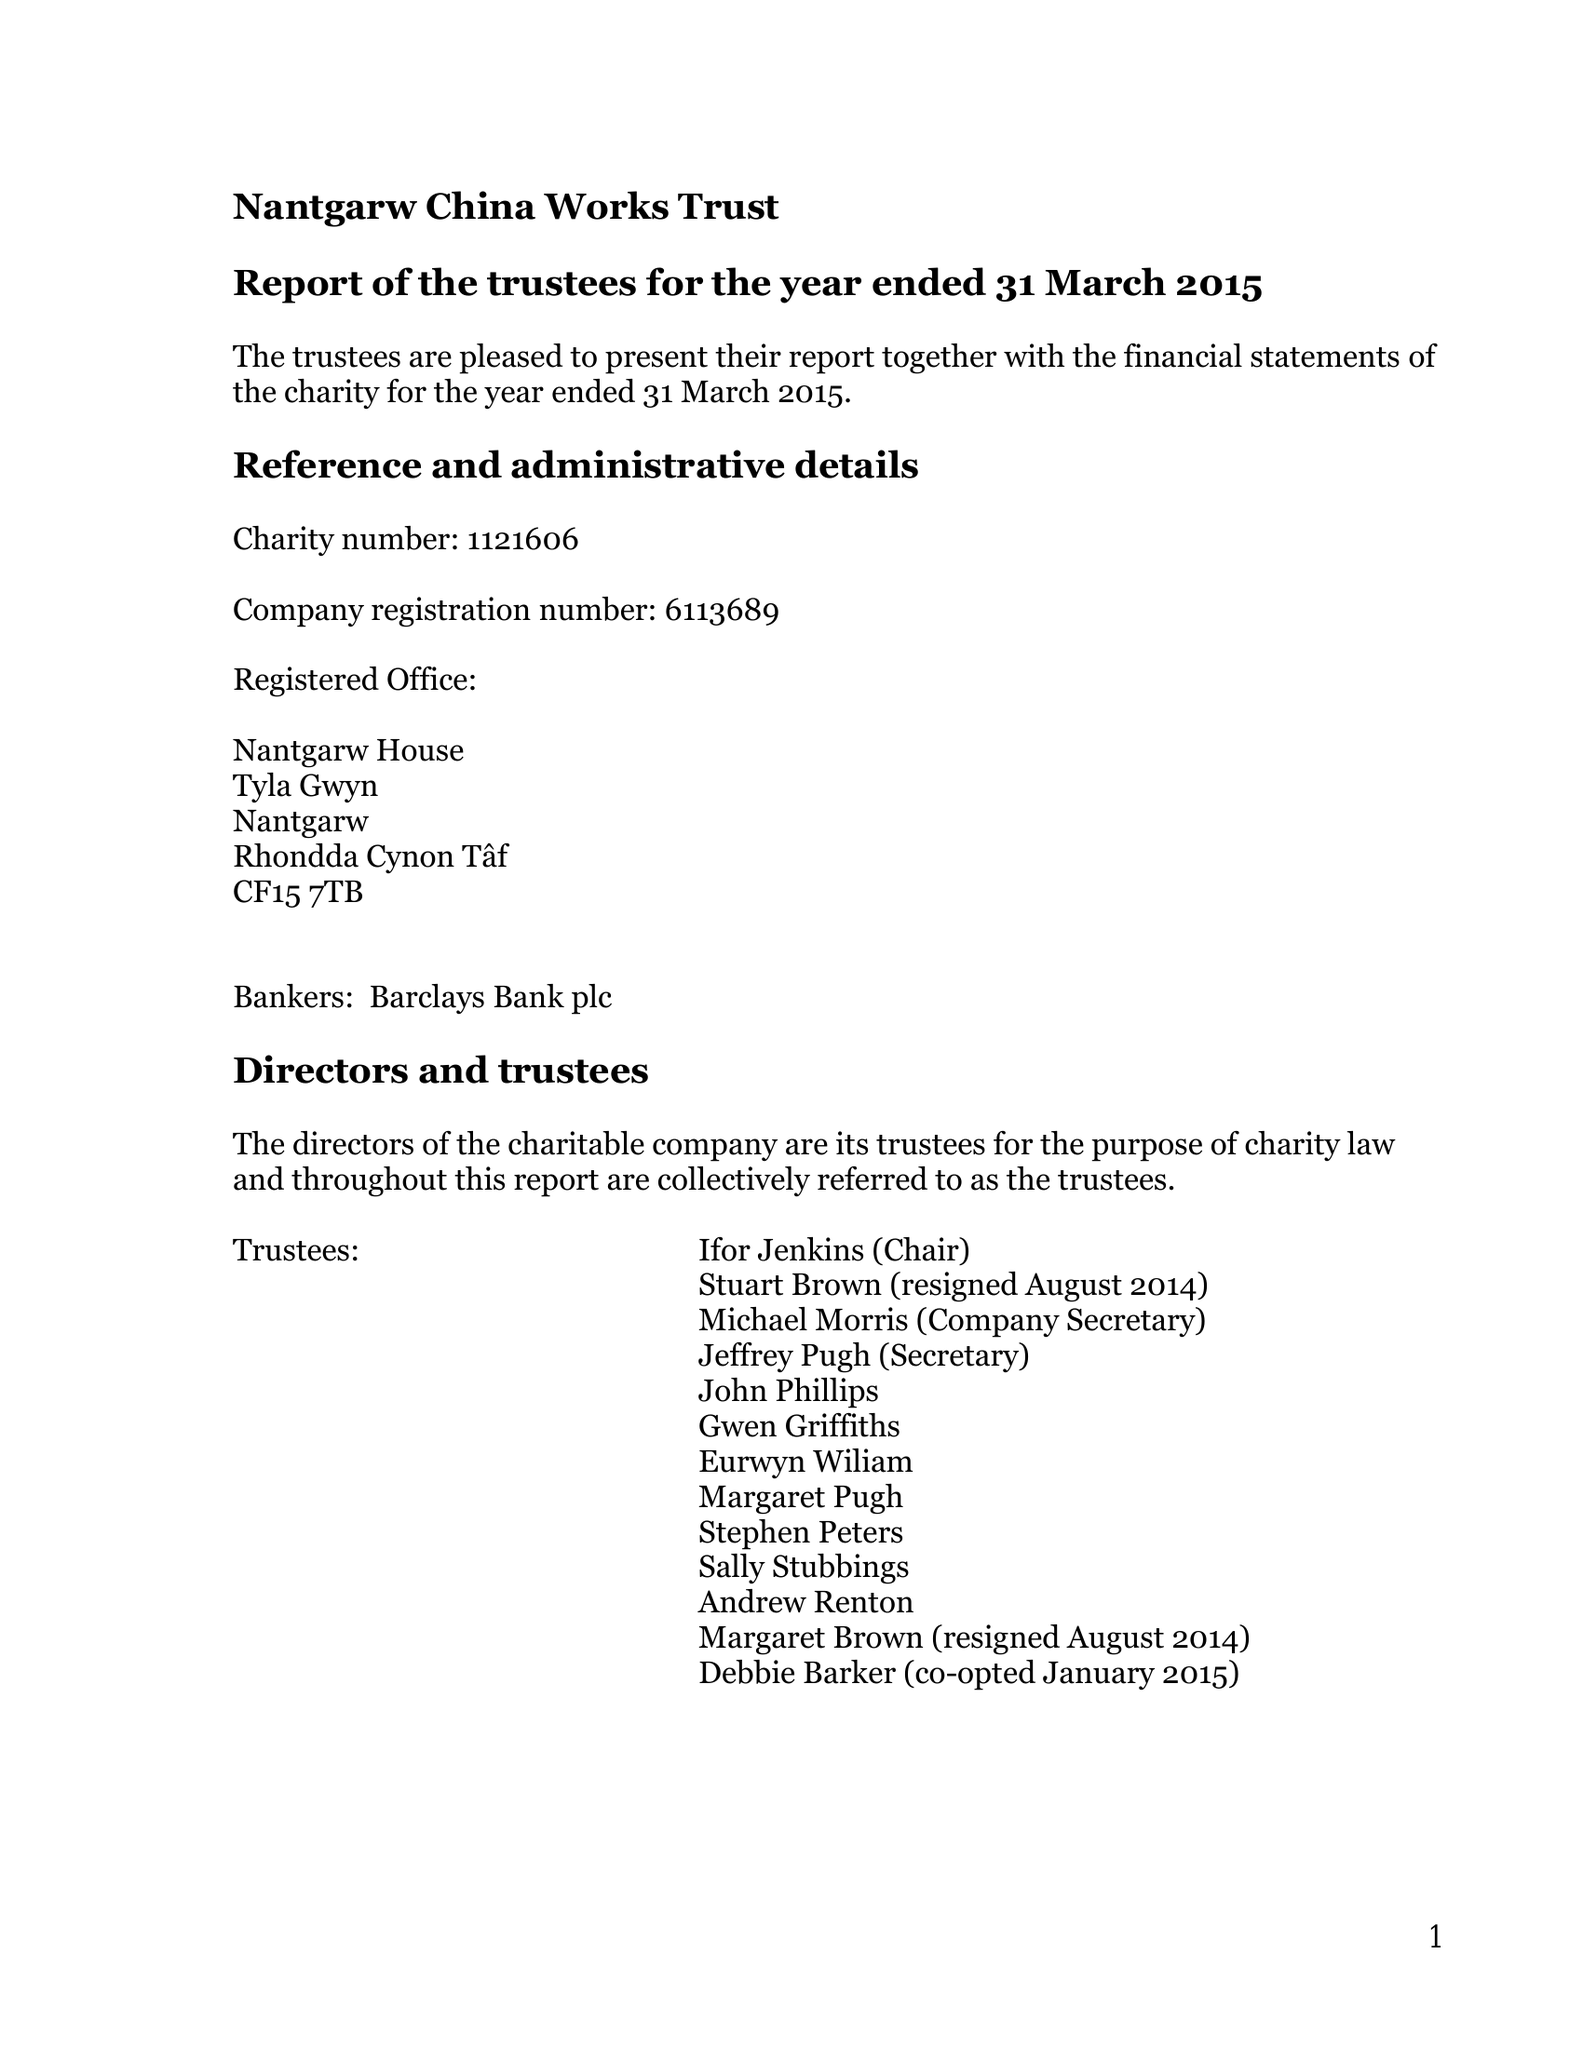What is the value for the income_annually_in_british_pounds?
Answer the question using a single word or phrase. 34746.00 